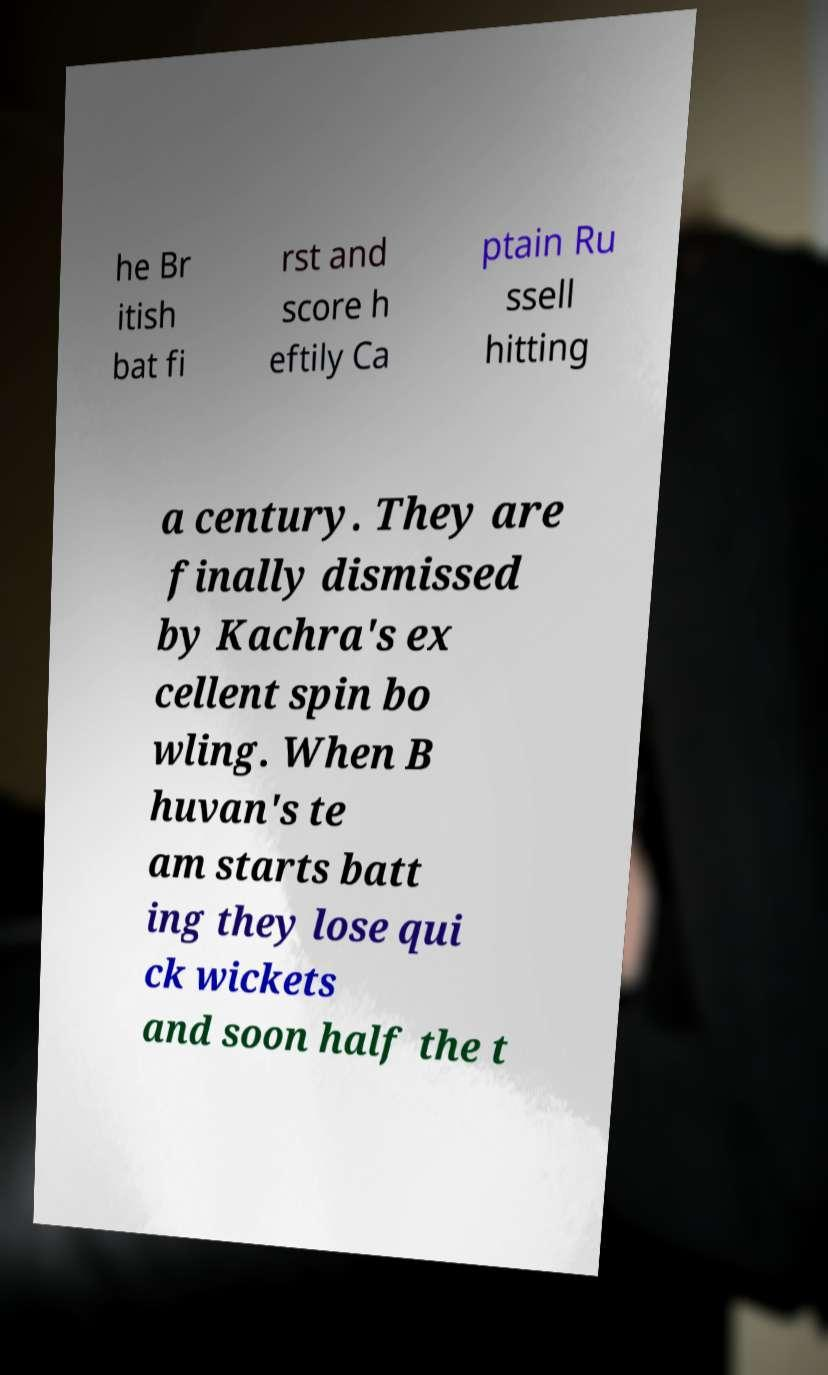There's text embedded in this image that I need extracted. Can you transcribe it verbatim? he Br itish bat fi rst and score h eftily Ca ptain Ru ssell hitting a century. They are finally dismissed by Kachra's ex cellent spin bo wling. When B huvan's te am starts batt ing they lose qui ck wickets and soon half the t 